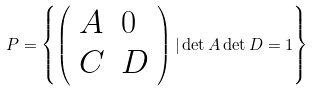Convert formula to latex. <formula><loc_0><loc_0><loc_500><loc_500>P = \left \{ \left ( \begin{array} { l l } A & { 0 } \\ C & D \end{array} \right ) | \det A \det D = 1 \right \}</formula> 